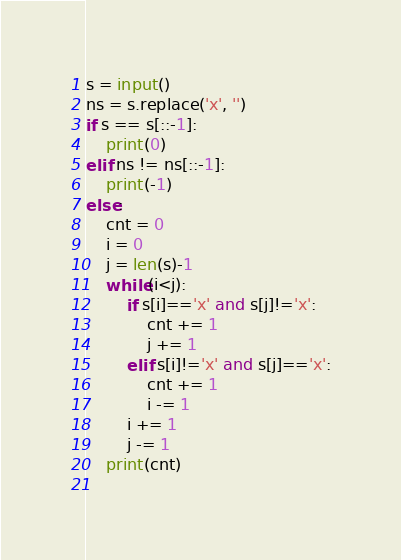Convert code to text. <code><loc_0><loc_0><loc_500><loc_500><_Python_>s = input()
ns = s.replace('x', '')
if s == s[::-1]:
    print(0)
elif ns != ns[::-1]:
    print(-1)
else:
    cnt = 0
    i = 0
    j = len(s)-1
    while(i<j):
        if s[i]=='x' and s[j]!='x':
            cnt += 1
            j += 1
        elif s[i]!='x' and s[j]=='x':
            cnt += 1
            i -= 1
        i += 1
        j -= 1
    print(cnt)
    
</code> 